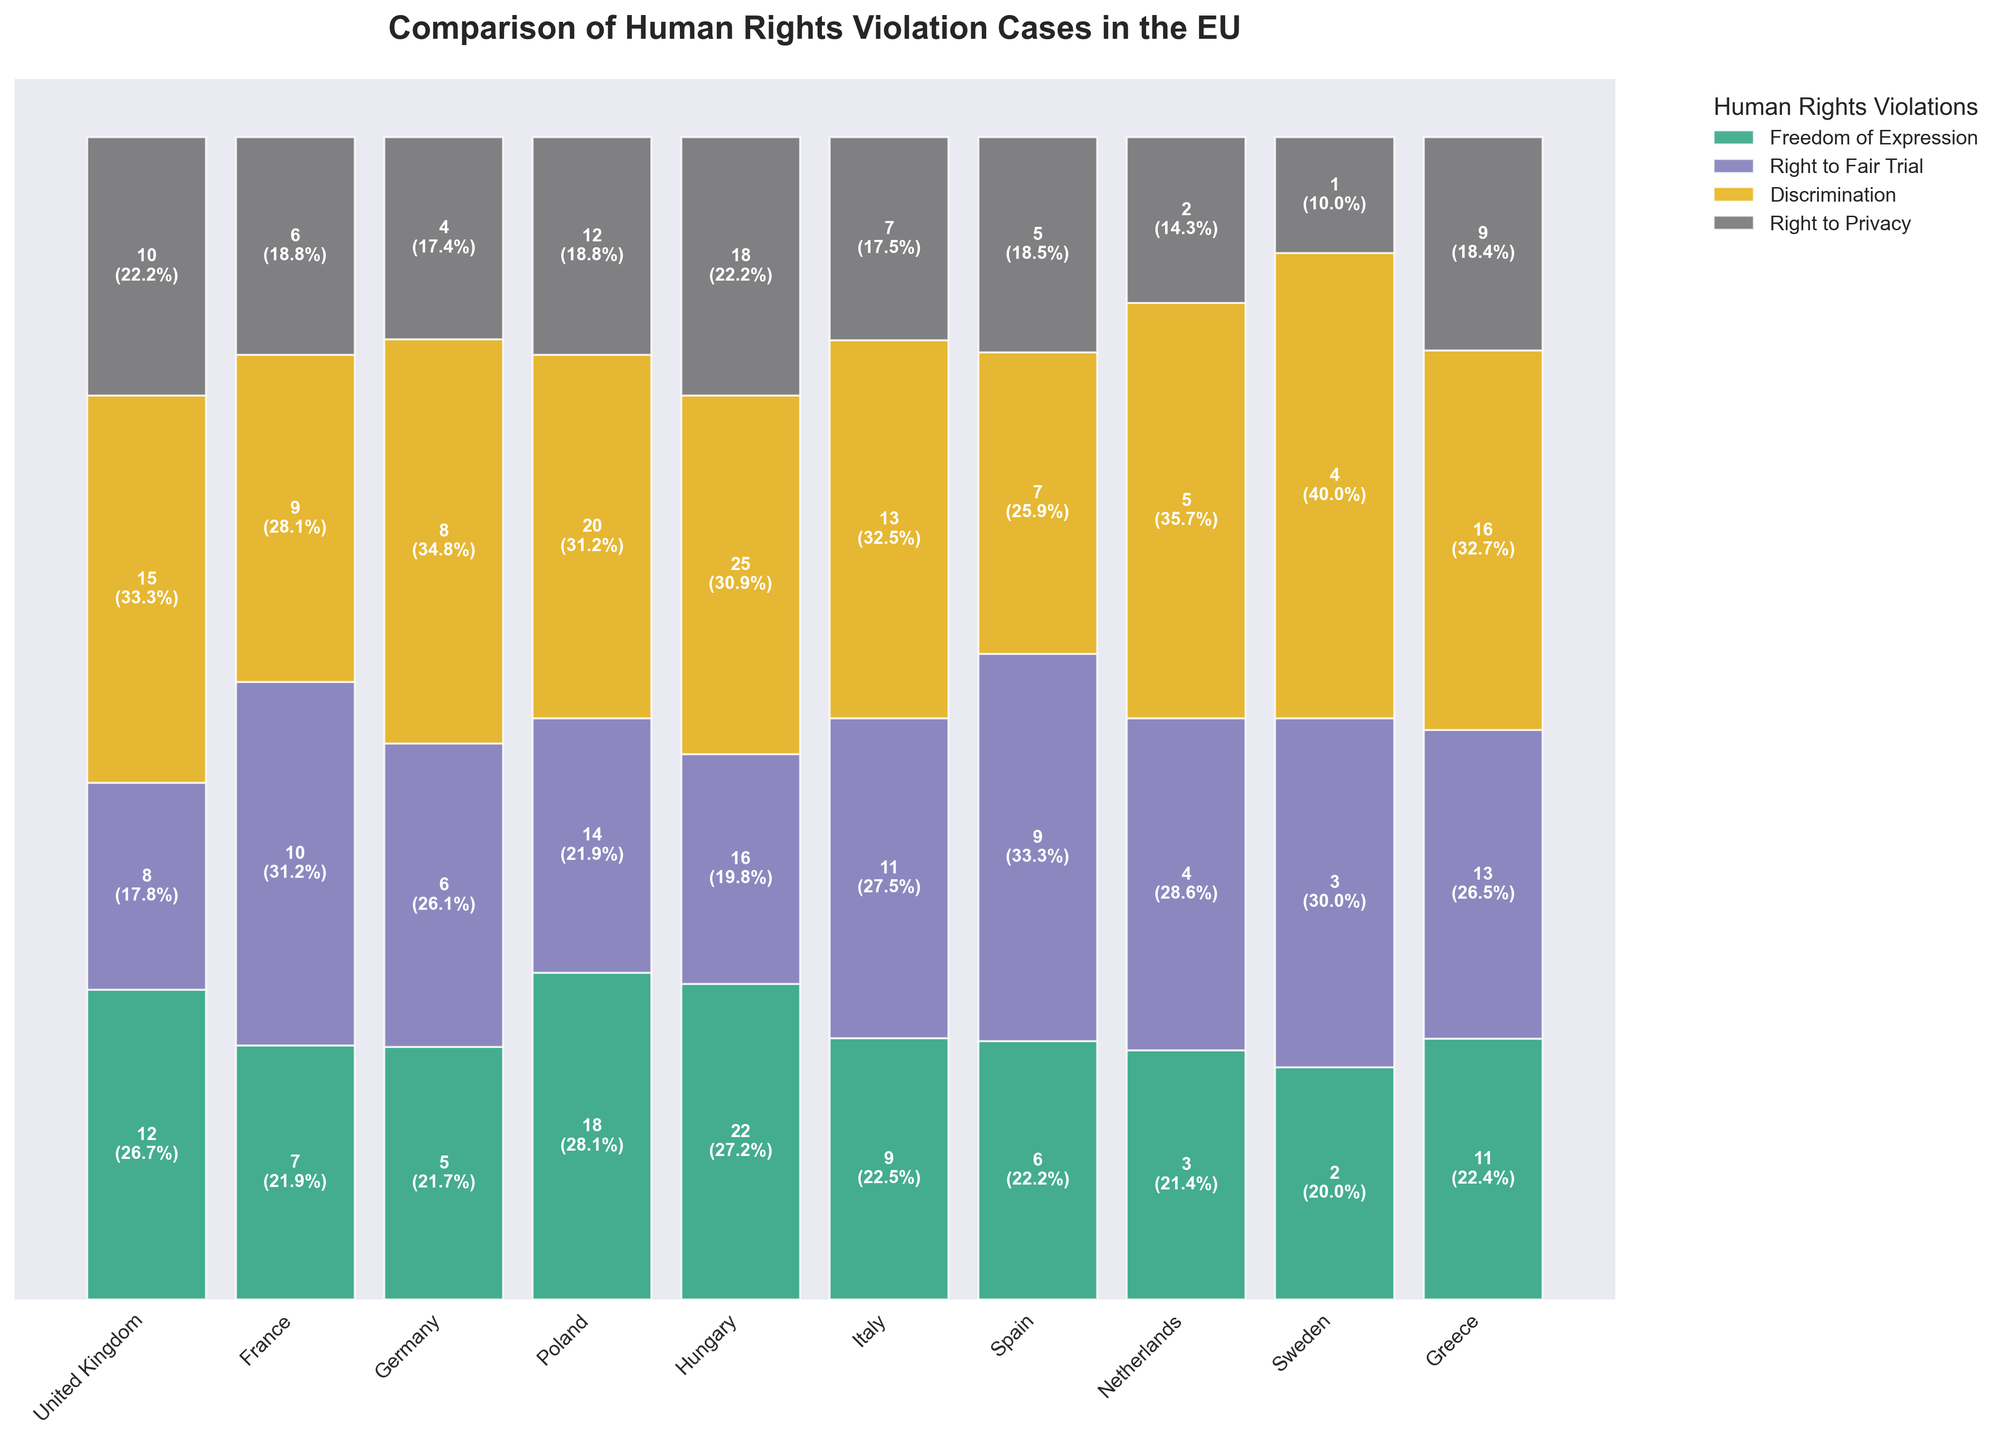What is the title of the plot? The title is usually at the top of the plot, summarizing what the plot is about.
Answer: Comparison of Human Rights Violation Cases in the EU Which member state has the highest number of discrimination cases? Look for the highest bar segment corresponding to "Discrimination" in the plot and identify the member state on the x-axis.
Answer: Hungary How does Italy compare to Germany in terms of right to fair trial cases? Compare the bar segments for "Right to Fair Trial" between Italy and Germany. Italy's segment is higher.
Answer: Italy has more Which type of violation occurs most frequently in Poland? Identify the tallest segment in Poland's bar and check the corresponding color legend to determine the type of violation.
Answer: Discrimination What percentage of the total human rights violation cases in Sweden is related to freedom of expression? Check Sweden's segment for "Freedom of Expression" and read the percentage shown in or on the bar.
Answer: 2% Between France and Spain, which member state has a higher total number of human rights violation cases? Sum the heights of all segments (consider segments' values) for France and Spain, and compare the totals. France has higher totals.
Answer: France How many right to privacy cases are reported in the Netherlands? Look at the bar segment for "Right to Privacy" in the Netherlands and read the number inside or at the top of the segment.
Answer: 2 Which member states have less than 10 freedom of expression cases? Identify the member states with lower segments in "Freedom of Expression" category than 10 and list them. Include France, Germany, Spain, Netherlands, and Sweden.
Answer: France, Germany, Spain, Netherlands, Sweden What is the total number of human rights violation cases in Greece? Sum up the segments' values for all types of violations in Greece. 11 + 13 + 16 + 9.
Answer: 49 Which violation type makes up the largest proportion of total violation cases in Hungary? Identify the tallest segment within Hungary and check the corresponding color legend for the type.
Answer: Discrimination 